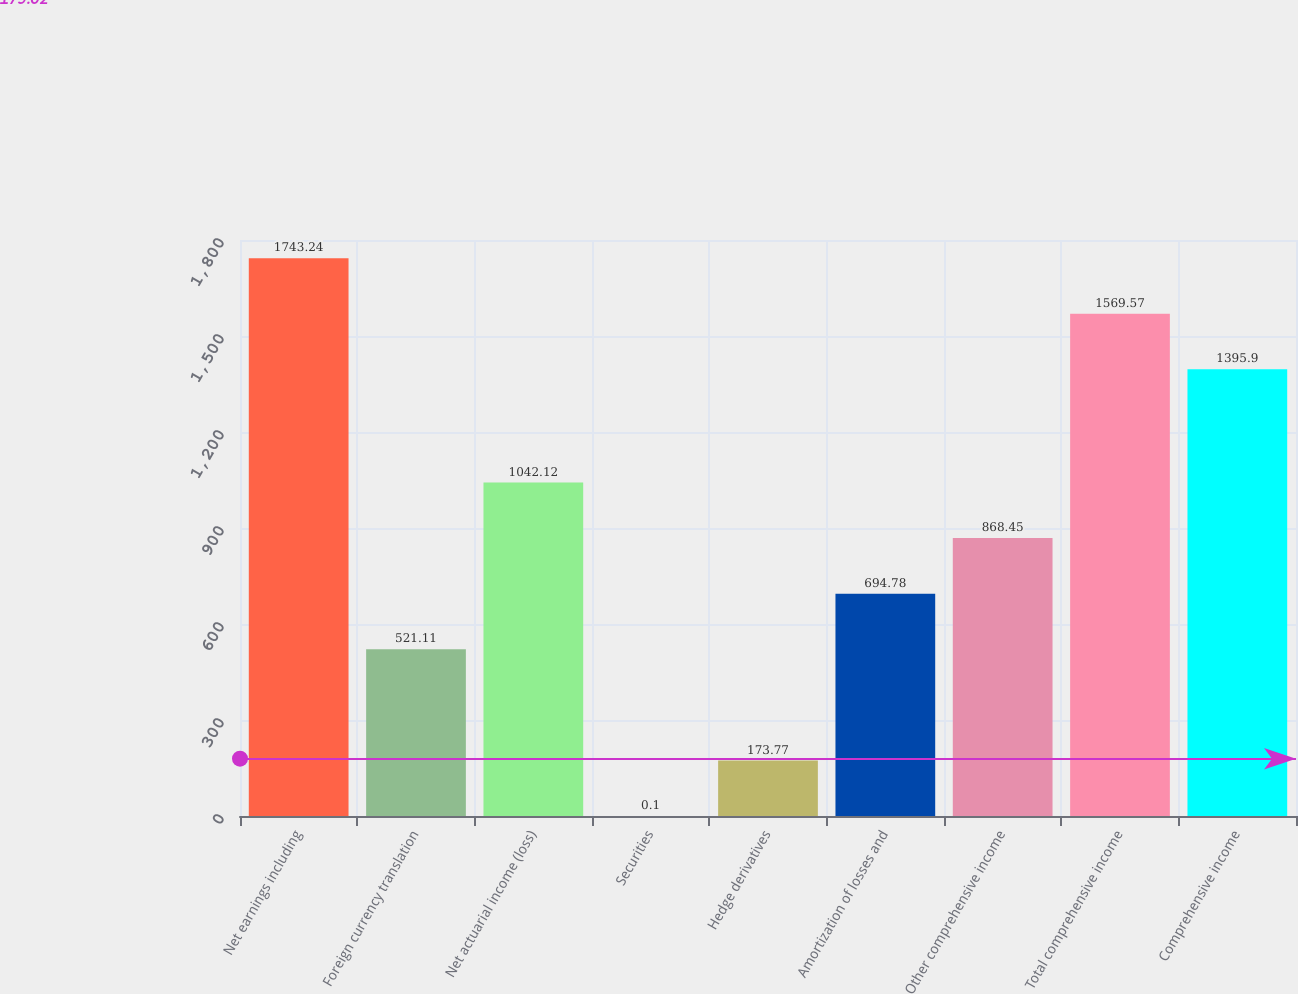Convert chart to OTSL. <chart><loc_0><loc_0><loc_500><loc_500><bar_chart><fcel>Net earnings including<fcel>Foreign currency translation<fcel>Net actuarial income (loss)<fcel>Securities<fcel>Hedge derivatives<fcel>Amortization of losses and<fcel>Other comprehensive income<fcel>Total comprehensive income<fcel>Comprehensive income<nl><fcel>1743.24<fcel>521.11<fcel>1042.12<fcel>0.1<fcel>173.77<fcel>694.78<fcel>868.45<fcel>1569.57<fcel>1395.9<nl></chart> 